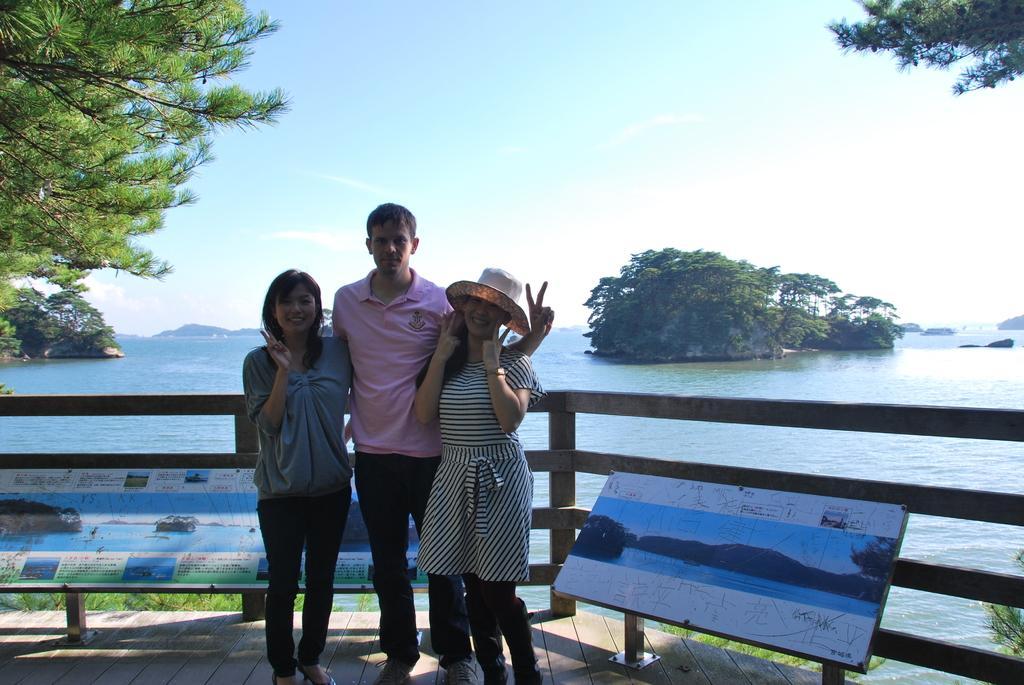Could you give a brief overview of what you see in this image? In the center of the image there are three people standing. There is a wooden fencing in the image. There are trees. In the background of the image there is water. 